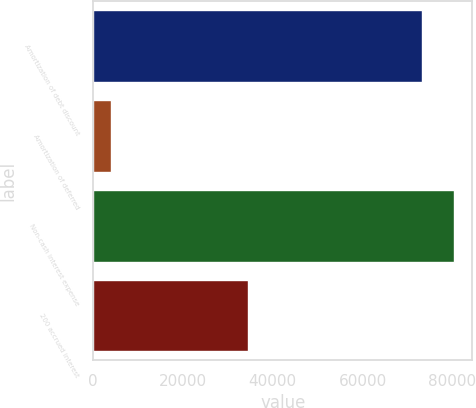Convert chart to OTSL. <chart><loc_0><loc_0><loc_500><loc_500><bar_chart><fcel>Amortization of debt discount<fcel>Amortization of deferred<fcel>Non-cash interest expense<fcel>200 accrued interest<nl><fcel>73130<fcel>4092<fcel>80443<fcel>34500<nl></chart> 